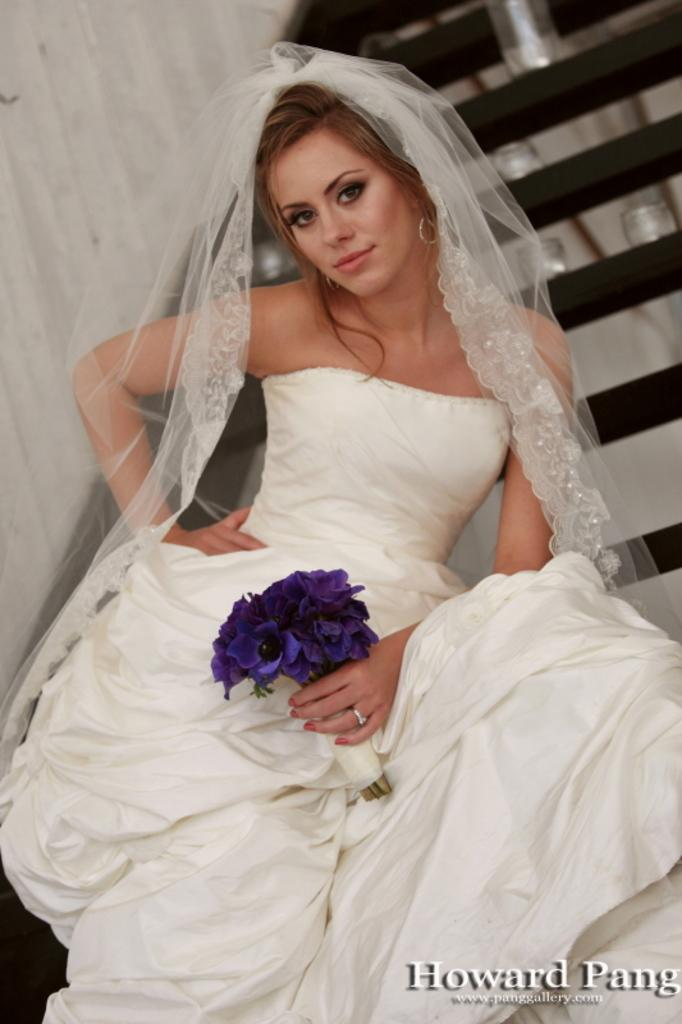Who is the main subject in the image? There is a woman in the image. What is the woman doing in the image? The woman is standing in the middle of the image and holding flowers. What is the woman's facial expression in the image? The woman is smiling in the image. What can be seen behind the woman in the image? There is a staircase and a wall behind the woman in the image. What type of country can be seen in the background of the image? There is no country visible in the image; it only shows a woman standing with flowers, a staircase, and a wall behind her. 